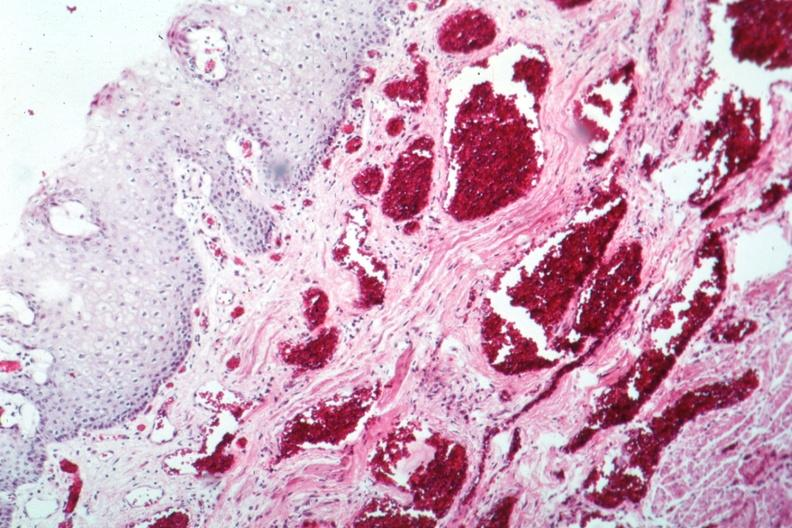what is present?
Answer the question using a single word or phrase. Gastrointestinal 